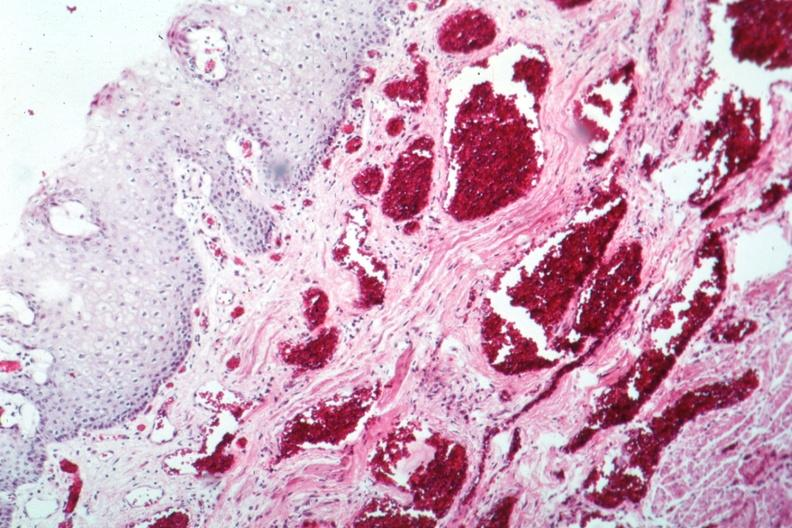what is present?
Answer the question using a single word or phrase. Gastrointestinal 